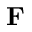<formula> <loc_0><loc_0><loc_500><loc_500>F</formula> 